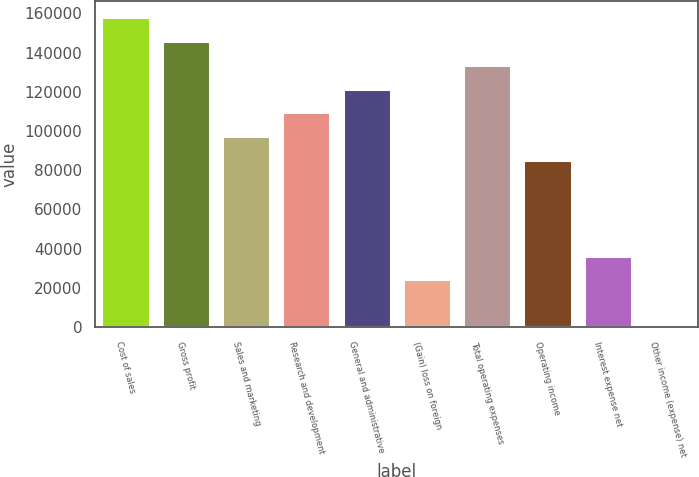Convert chart to OTSL. <chart><loc_0><loc_0><loc_500><loc_500><bar_chart><fcel>Cost of sales<fcel>Gross profit<fcel>Sales and marketing<fcel>Research and development<fcel>General and administrative<fcel>(Gain) loss on foreign<fcel>Total operating expenses<fcel>Operating income<fcel>Interest expense net<fcel>Other income (expense) net<nl><fcel>158103<fcel>145944<fcel>97308<fcel>109467<fcel>121626<fcel>24354<fcel>133785<fcel>85149<fcel>36513<fcel>36<nl></chart> 